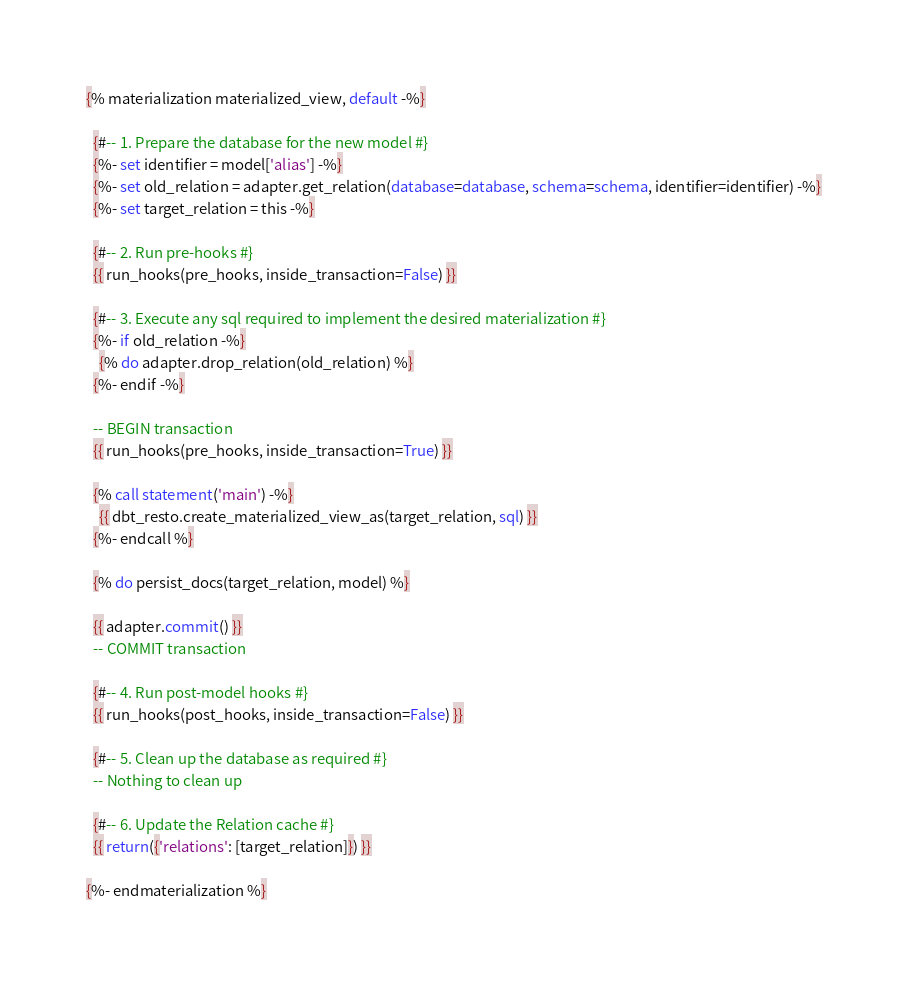Convert code to text. <code><loc_0><loc_0><loc_500><loc_500><_SQL_>{% materialization materialized_view, default -%}

  {#-- 1. Prepare the database for the new model #}
  {%- set identifier = model['alias'] -%}
  {%- set old_relation = adapter.get_relation(database=database, schema=schema, identifier=identifier) -%}
  {%- set target_relation = this -%}

  {#-- 2. Run pre-hooks #}
  {{ run_hooks(pre_hooks, inside_transaction=False) }}

  {#-- 3. Execute any sql required to implement the desired materialization #}
  {%- if old_relation -%}
    {% do adapter.drop_relation(old_relation) %}
  {%- endif -%}

  -- BEGIN transaction
  {{ run_hooks(pre_hooks, inside_transaction=True) }}

  {% call statement('main') -%}
    {{ dbt_resto.create_materialized_view_as(target_relation, sql) }}
  {%- endcall %}

  {% do persist_docs(target_relation, model) %}

  {{ adapter.commit() }}
  -- COMMIT transaction

  {#-- 4. Run post-model hooks #}
  {{ run_hooks(post_hooks, inside_transaction=False) }}

  {#-- 5. Clean up the database as required #}
  -- Nothing to clean up

  {#-- 6. Update the Relation cache #}
  {{ return({'relations': [target_relation]}) }}

{%- endmaterialization %}</code> 